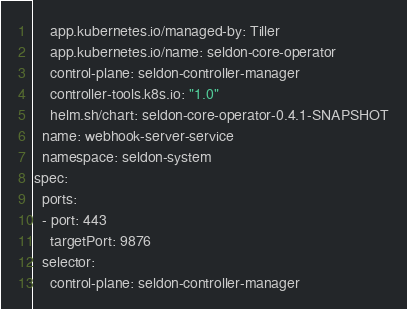<code> <loc_0><loc_0><loc_500><loc_500><_YAML_>    app.kubernetes.io/managed-by: Tiller
    app.kubernetes.io/name: seldon-core-operator
    control-plane: seldon-controller-manager
    controller-tools.k8s.io: "1.0"
    helm.sh/chart: seldon-core-operator-0.4.1-SNAPSHOT
  name: webhook-server-service
  namespace: seldon-system
spec:
  ports:
  - port: 443
    targetPort: 9876
  selector:
    control-plane: seldon-controller-manager
</code> 